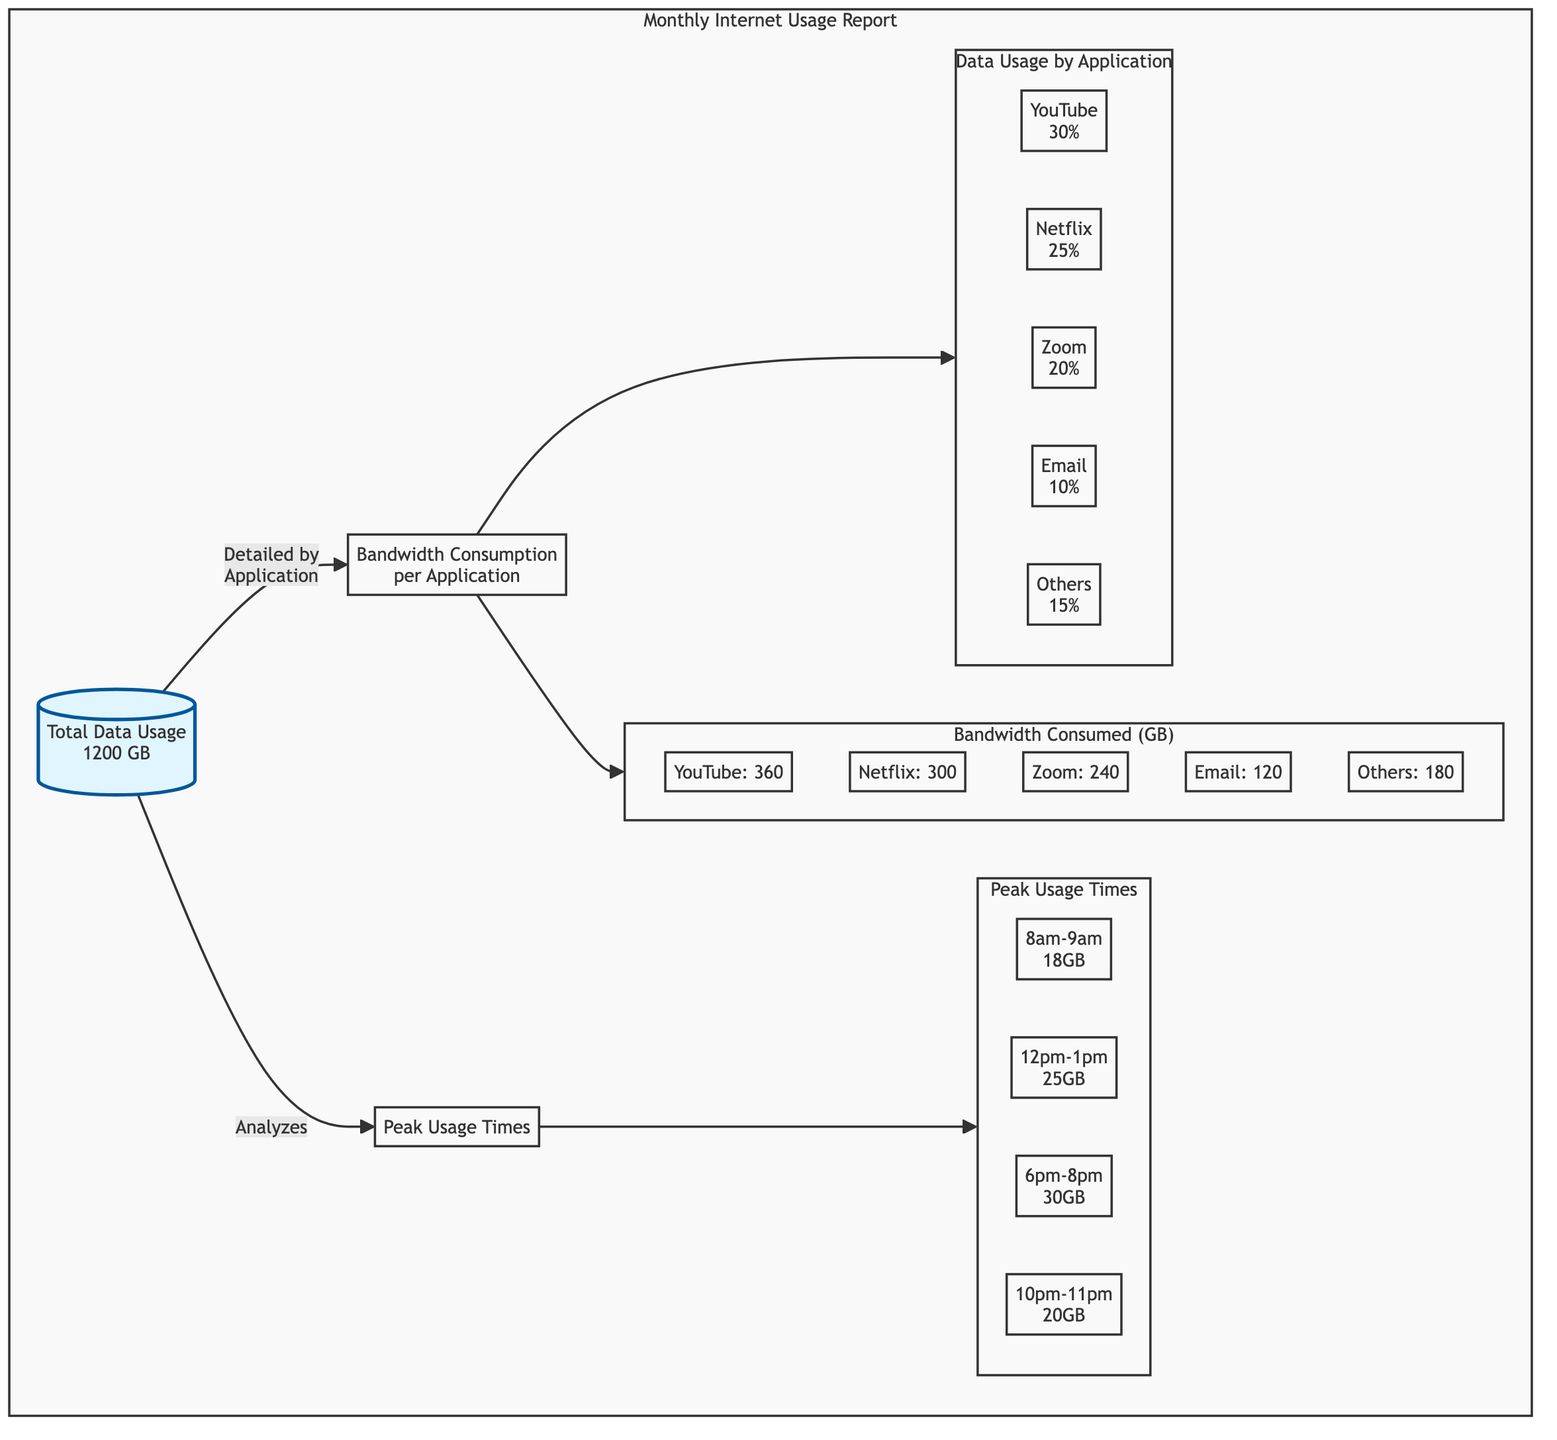What is the total data usage for the month? The diagram states that the total data usage is 1200 GB, which is explicitly mentioned in the Total Data Usage node.
Answer: 1200 GB What percentage of data usage is attributed to YouTube? In the PieChart subgraph, YouTube is shown to have 30% of the total data usage, which is clearly indicated next to its name.
Answer: 30% Which application has the highest bandwidth consumption in GB? By examining the BarGraph subgraph, YouTube has the highest consumption value of 360 GB, which is noted alongside its name.
Answer: YouTube How many peak usage times are listed in the report? The Timeline subgraph lists four distinct peak usage times as nodes, which are clearly separated by arrows leading from the Peak Usage Times node.
Answer: 4 What is the total bandwidth consumed by Netflix? The BarGraph related to application bandwidth shows Netflix consuming 300 GB, which is specified directly in its corresponding node.
Answer: 300 GB What time frame shows the most data usage? The Timeline indicates that the 6pm-8pm slot has the highest data usage value of 30GB, visibly marked beside this time period.
Answer: 6pm-8pm How does total data usage relate to bandwidth consumption per application? The total data usage of 1200 GB connects to the Bandwidth Consumption per Application node, which divides this total among specific applications, showing their individual consumptions that sum up to the total usage.
Answer: Total Data Usage relates to Bandwidth Consumption per Application What is the bandwidth consumption of Zoom? The BarGraph node specifies that the bandwidth consumption for Zoom is 240 GB, indicated alongside its entry.
Answer: 240 GB 